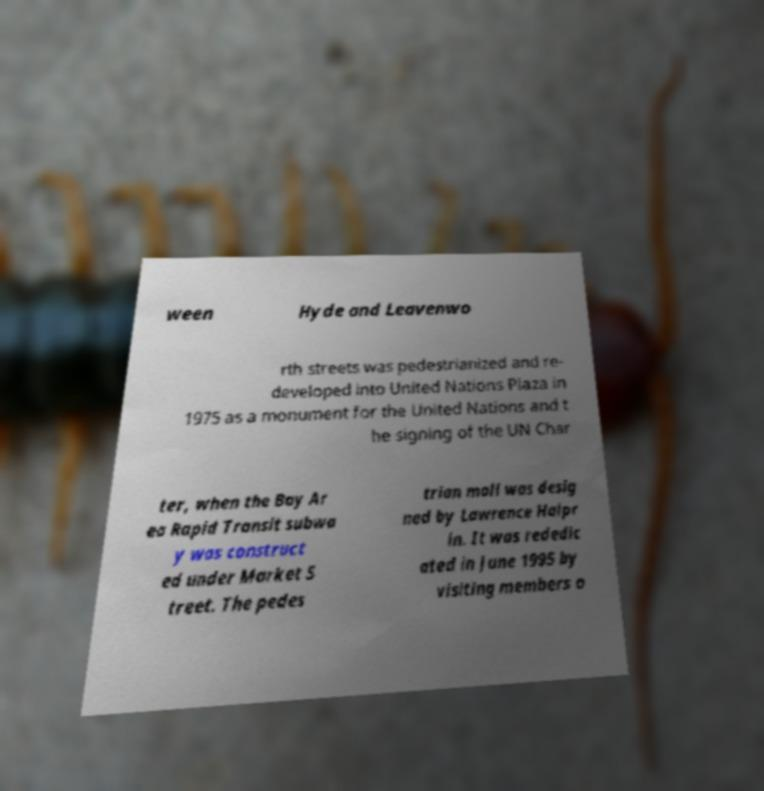I need the written content from this picture converted into text. Can you do that? ween Hyde and Leavenwo rth streets was pedestrianized and re- developed into United Nations Plaza in 1975 as a monument for the United Nations and t he signing of the UN Char ter, when the Bay Ar ea Rapid Transit subwa y was construct ed under Market S treet. The pedes trian mall was desig ned by Lawrence Halpr in. It was rededic ated in June 1995 by visiting members o 